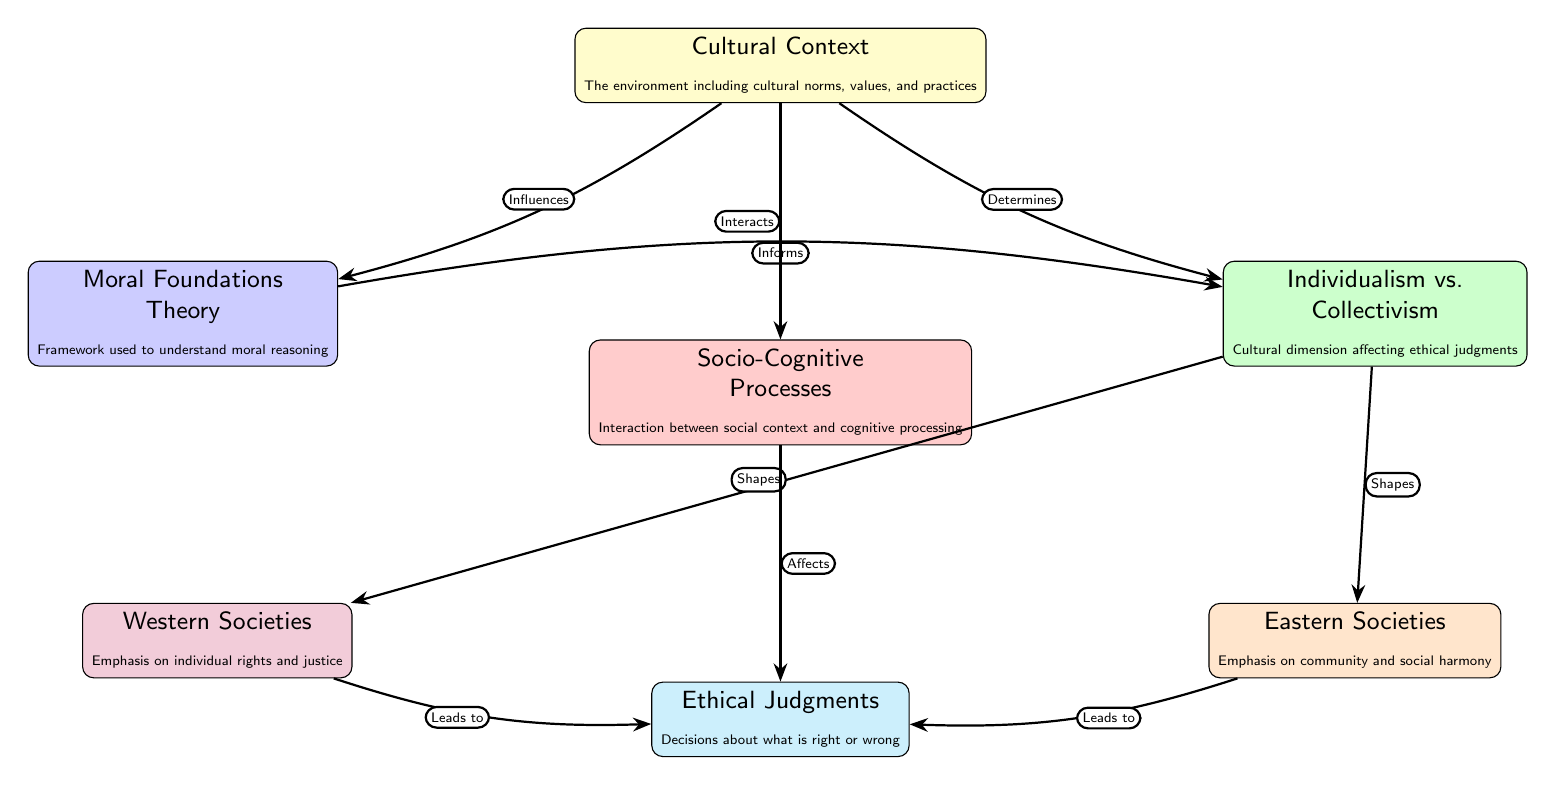What is the central node in the diagram? The diagram presents cultural context as the central node because it provides the foundational information that influences the other components within the framework.
Answer: Cultural Context How many nodes are present in the diagram? By counting each distinct entity in the diagram, there are a total of seven nodes depicted, including the central node and its connected components.
Answer: 7 Which two nodes are directly connected to the “Cultural Context” node? The nodes directly connected to the "Cultural Context" node are "Moral Foundations Theory" and "Socio-Cognitive Processes", as they have direct edges stemming from the central node.
Answer: Moral Foundations Theory and Socio-Cognitive Processes What does the "Socio-Cognitive Processes" node affect? The "Socio-Cognitive Processes" node affects "Ethical Judgments", indicated by the edge directly pointing from the socio-cognitive node to the ethical judgments node.
Answer: Ethical Judgments What cultural emphasis is associated with Western societies in the diagram? Western societies are associated with an emphasis on individual rights and justice, as described in the node that pertains specifically to this cultural group within the diagram's context.
Answer: Individual rights and justice How does the "Cultural Context" node interact with "Socio-Cognitive Processes"? The "Cultural Context" node interacts with "Socio-Cognitive Processes", indicating that it plays a role in shaping how social factors influence the cognitive processes related to moral reasoning.
Answer: Interacts What relationship exists between "Individualism vs. Collectivism" and the nodes for Eastern and Western societies? The "Individualism vs. Collectivism" node shapes the ethical judgments in both Western and Eastern societies, suggesting that cultural orientation influences moral reasoning in these distinct contexts.
Answer: Shapes How do "Western Societies" and "Eastern Societies" lead to "Ethical Judgments"? Both "Western Societies" and "Eastern Societies" lead to "Ethical Judgments" by connecting through their respective edges from the societal nodes to the ethical judgments node, indicating that different cultural frameworks produce different moral conclusions.
Answer: Leads to What theoretical framework is mentioned in the diagram related to moral reasoning? The theoretical framework mentioned in the diagram is the "Moral Foundations Theory", which provides a basis for understanding how moral reasoning is structured across diverse cultural contexts.
Answer: Moral Foundations Theory 